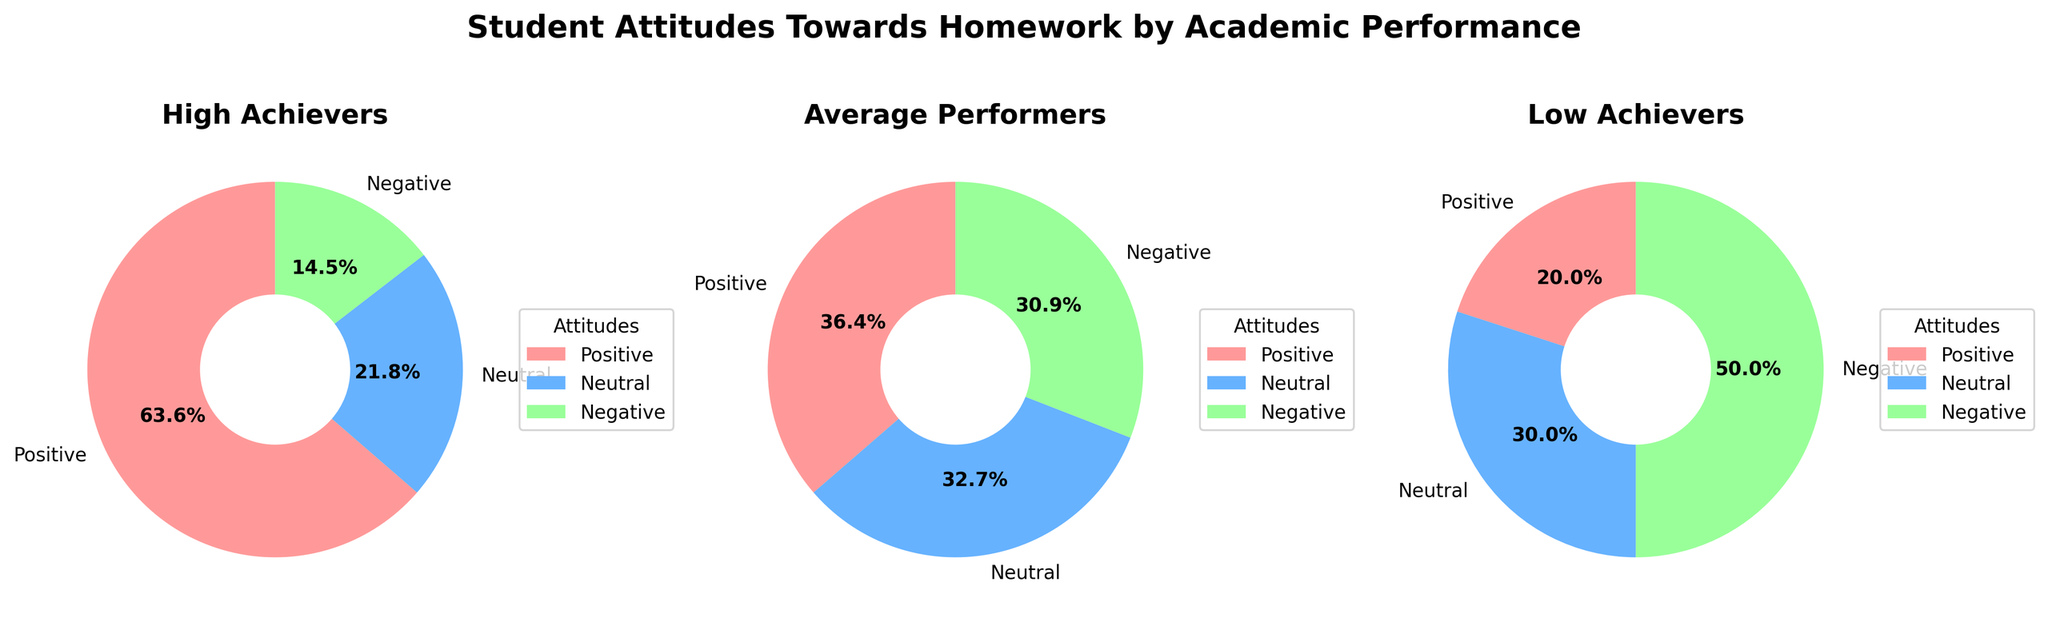What's the total percentage of students who have a positive attitude towards homework across all performance groups? First, add the percentages for positive attitudes across all groups: 35 (High Achievers) + 20 (Average Performers) + 10 (Low Achievers). So, the total percentage is 35 + 20 + 10 = 65%.
Answer: 65% Which group has the highest percentage of students with a negative attitude towards homework? Compare the negative attitude percentages across groups: High Achievers (8%), Average Performers (17%), and Low Achievers (25%). The percentage for Low Achievers is the highest.
Answer: Low Achievers How does the percentage of students with a neutral attitude in the High Achiever group compare to the Low Achiever group? Look at the neutral attitude percentages for High Achievers (12%) and Low Achievers (15%). Compare these two percentages. The percentage in the Low Achiever group is higher than in the High Achiever group.
Answer: Low Achievers have higher neutral percentages What is the difference in the percentage of students with a positive attitude between High Achievers and Average Performers? Subtract the percentage of students with a positive attitude in Average Performers from High Achievers: 35% - 20% = 15%.
Answer: 15% Which attitude is least common among High Achievers? Compare the percentages of the three attitudes for High Achievers: Positive (35%), Neutral (12%), and Negative (8%). The least common attitude is Negative.
Answer: Negative For Average Performers, how much higher is the percentage of students with a neutral attitude compared to those with a negative attitude? Subtract the percentage of students with a negative attitude from those with a neutral attitude among Average Performers: 18% - 17% = 1%.
Answer: 1% What proportion of Low Achievers has either a positive or neutral attitude towards homework? Add the percentages of positive and neutral attitudes for Low Achievers: 10% (Positive) + 15% (Neutral) = 25%.
Answer: 25% In terms of positive attitudes, how much of a difference is there between High Achievers and Low Achievers? Subtract the percentage of students with a positive attitude in Low Achievers from High Achievers: 35% - 10% = 25%.
Answer: 25% What is the most common attitude among Average Performers? Compare the percentages of the three attitudes for Average Performers: Positive (20%), Neutral (18%), and Negative (17%). The most common attitude is Positive.
Answer: Positive 